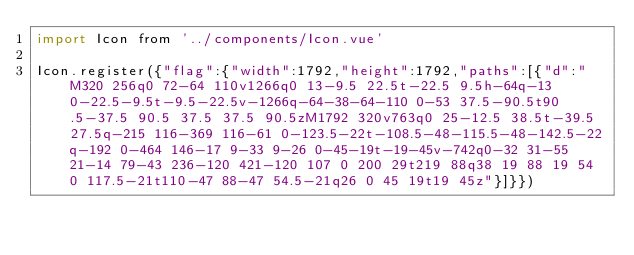<code> <loc_0><loc_0><loc_500><loc_500><_JavaScript_>import Icon from '../components/Icon.vue'

Icon.register({"flag":{"width":1792,"height":1792,"paths":[{"d":"M320 256q0 72-64 110v1266q0 13-9.5 22.5t-22.5 9.5h-64q-13 0-22.5-9.5t-9.5-22.5v-1266q-64-38-64-110 0-53 37.5-90.5t90.5-37.5 90.5 37.5 37.5 90.5zM1792 320v763q0 25-12.5 38.5t-39.5 27.5q-215 116-369 116-61 0-123.5-22t-108.5-48-115.5-48-142.5-22q-192 0-464 146-17 9-33 9-26 0-45-19t-19-45v-742q0-32 31-55 21-14 79-43 236-120 421-120 107 0 200 29t219 88q38 19 88 19 54 0 117.5-21t110-47 88-47 54.5-21q26 0 45 19t19 45z"}]}})
</code> 